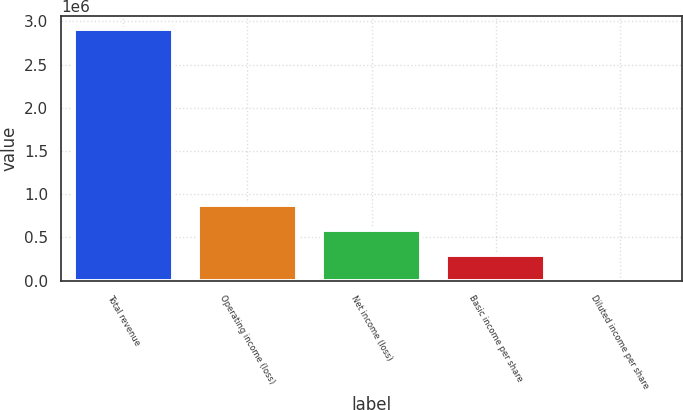Convert chart to OTSL. <chart><loc_0><loc_0><loc_500><loc_500><bar_chart><fcel>Total revenue<fcel>Operating income (loss)<fcel>Net income (loss)<fcel>Basic income per share<fcel>Diluted income per share<nl><fcel>2.91499e+06<fcel>874498<fcel>582999<fcel>291500<fcel>0.73<nl></chart> 